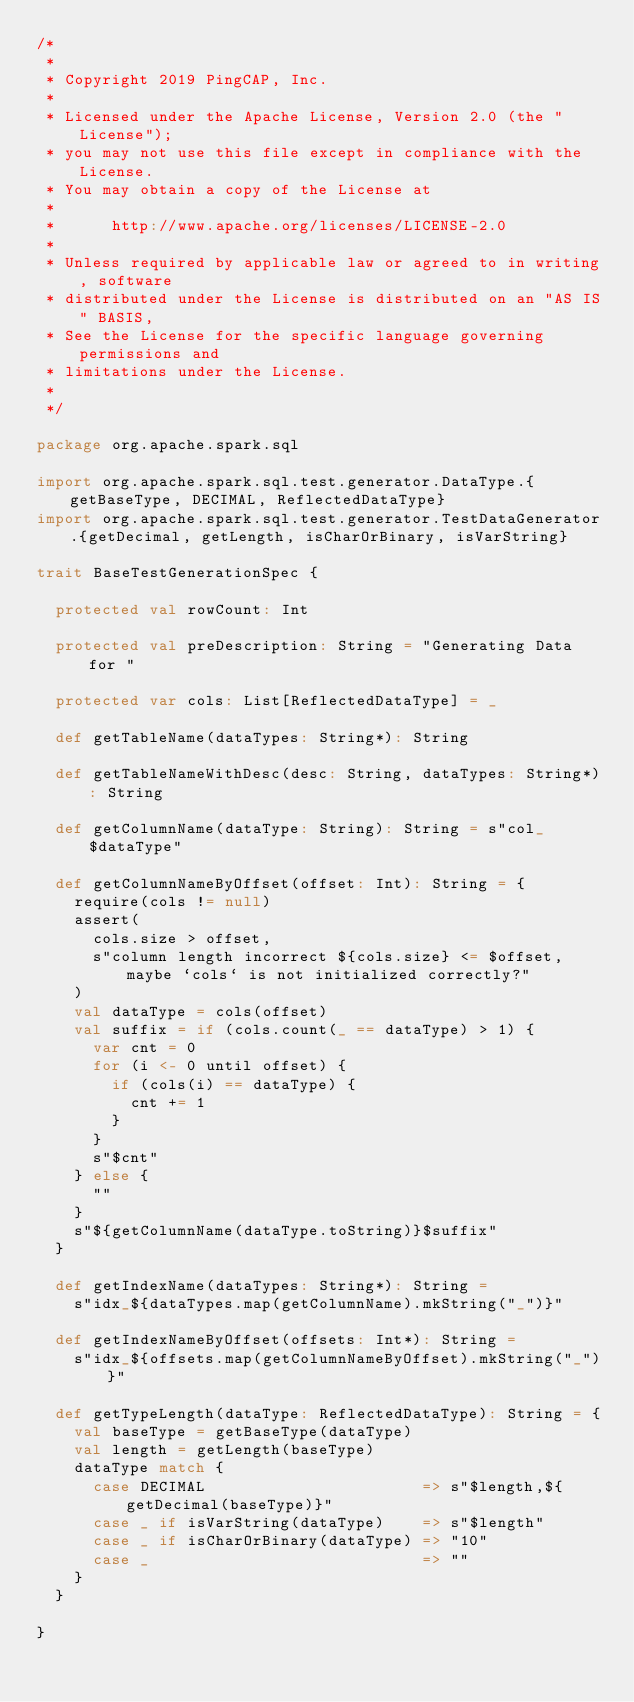<code> <loc_0><loc_0><loc_500><loc_500><_Scala_>/*
 *
 * Copyright 2019 PingCAP, Inc.
 *
 * Licensed under the Apache License, Version 2.0 (the "License");
 * you may not use this file except in compliance with the License.
 * You may obtain a copy of the License at
 *
 *      http://www.apache.org/licenses/LICENSE-2.0
 *
 * Unless required by applicable law or agreed to in writing, software
 * distributed under the License is distributed on an "AS IS" BASIS,
 * See the License for the specific language governing permissions and
 * limitations under the License.
 *
 */

package org.apache.spark.sql

import org.apache.spark.sql.test.generator.DataType.{getBaseType, DECIMAL, ReflectedDataType}
import org.apache.spark.sql.test.generator.TestDataGenerator.{getDecimal, getLength, isCharOrBinary, isVarString}

trait BaseTestGenerationSpec {

  protected val rowCount: Int

  protected val preDescription: String = "Generating Data for "

  protected var cols: List[ReflectedDataType] = _

  def getTableName(dataTypes: String*): String

  def getTableNameWithDesc(desc: String, dataTypes: String*): String

  def getColumnName(dataType: String): String = s"col_$dataType"

  def getColumnNameByOffset(offset: Int): String = {
    require(cols != null)
    assert(
      cols.size > offset,
      s"column length incorrect ${cols.size} <= $offset, maybe `cols` is not initialized correctly?"
    )
    val dataType = cols(offset)
    val suffix = if (cols.count(_ == dataType) > 1) {
      var cnt = 0
      for (i <- 0 until offset) {
        if (cols(i) == dataType) {
          cnt += 1
        }
      }
      s"$cnt"
    } else {
      ""
    }
    s"${getColumnName(dataType.toString)}$suffix"
  }

  def getIndexName(dataTypes: String*): String =
    s"idx_${dataTypes.map(getColumnName).mkString("_")}"

  def getIndexNameByOffset(offsets: Int*): String =
    s"idx_${offsets.map(getColumnNameByOffset).mkString("_")}"

  def getTypeLength(dataType: ReflectedDataType): String = {
    val baseType = getBaseType(dataType)
    val length = getLength(baseType)
    dataType match {
      case DECIMAL                       => s"$length,${getDecimal(baseType)}"
      case _ if isVarString(dataType)    => s"$length"
      case _ if isCharOrBinary(dataType) => "10"
      case _                             => ""
    }
  }

}
</code> 